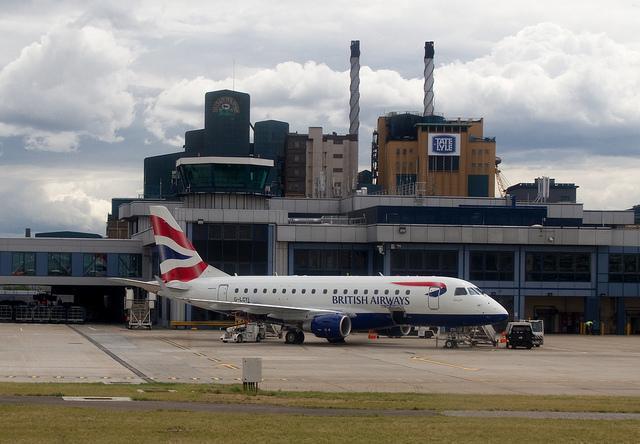What is placed in the underneath of a plane storage?
Select the correct answer and articulate reasoning with the following format: 'Answer: answer
Rationale: rationale.'
Options: Passangers, luggage, flight attendant, pilot. Answer: luggage.
Rationale: Luggage is loaded into the bottom of planes. vehicles are parked nbear a plane at an airport. 